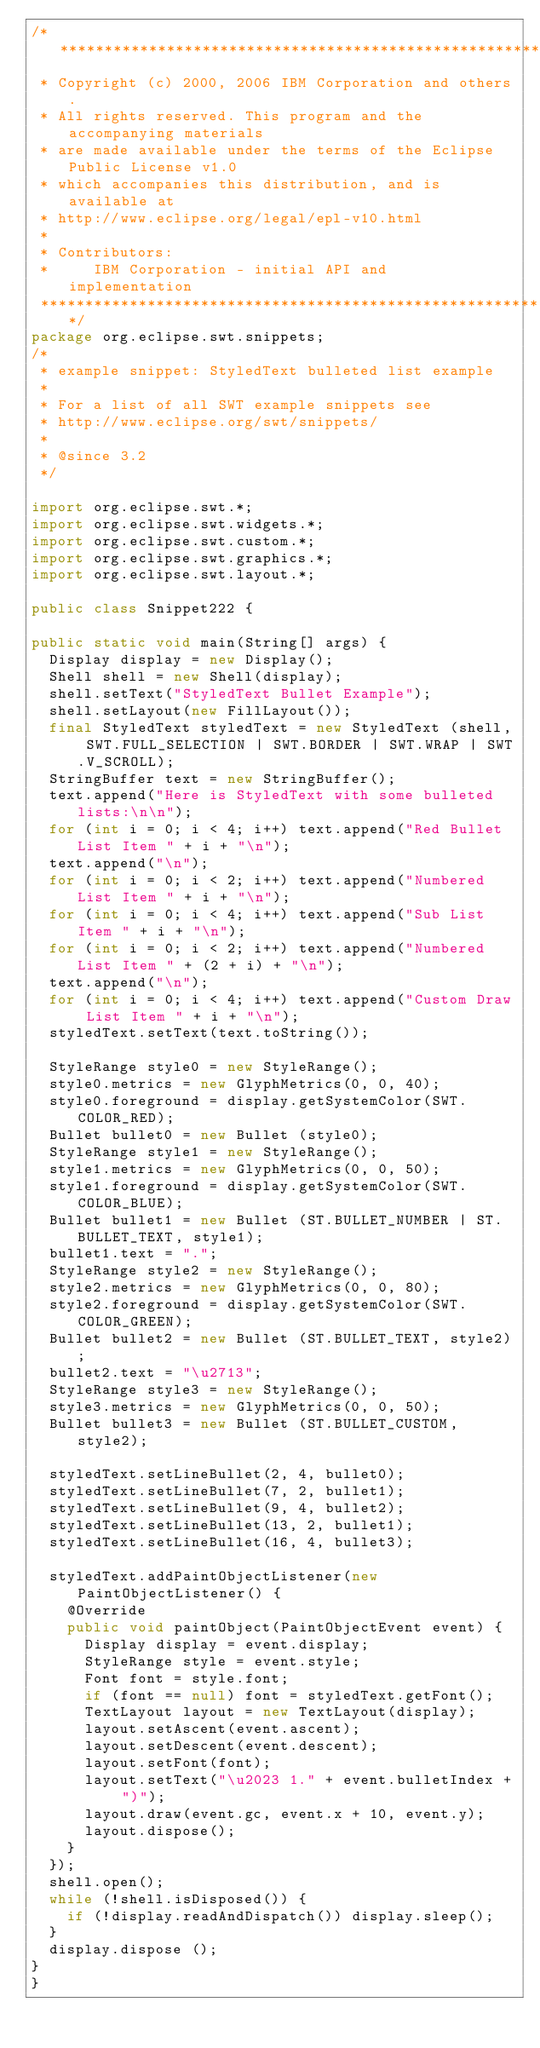<code> <loc_0><loc_0><loc_500><loc_500><_Java_>/*******************************************************************************
 * Copyright (c) 2000, 2006 IBM Corporation and others.
 * All rights reserved. This program and the accompanying materials
 * are made available under the terms of the Eclipse Public License v1.0
 * which accompanies this distribution, and is available at
 * http://www.eclipse.org/legal/epl-v10.html
 *
 * Contributors:
 *     IBM Corporation - initial API and implementation
 *******************************************************************************/
package org.eclipse.swt.snippets;
/* 
 * example snippet: StyledText bulleted list example
 *
 * For a list of all SWT example snippets see
 * http://www.eclipse.org/swt/snippets/
 * 
 * @since 3.2
 */

import org.eclipse.swt.*;
import org.eclipse.swt.widgets.*;
import org.eclipse.swt.custom.*;
import org.eclipse.swt.graphics.*;
import org.eclipse.swt.layout.*;

public class Snippet222 {
	
public static void main(String[] args) {	
	Display display = new Display();
	Shell shell = new Shell(display);
	shell.setText("StyledText Bullet Example");
	shell.setLayout(new FillLayout());
	final StyledText styledText = new StyledText (shell, SWT.FULL_SELECTION | SWT.BORDER | SWT.WRAP | SWT.V_SCROLL);
	StringBuffer text = new StringBuffer();
	text.append("Here is StyledText with some bulleted lists:\n\n");
	for (int i = 0; i < 4; i++) text.append("Red Bullet List Item " + i + "\n");
	text.append("\n");
	for (int i = 0; i < 2; i++) text.append("Numbered List Item " + i + "\n");
	for (int i = 0; i < 4; i++) text.append("Sub List Item " + i + "\n");
	for (int i = 0; i < 2; i++) text.append("Numbered List Item " + (2 + i) + "\n");
	text.append("\n");
	for (int i = 0; i < 4; i++) text.append("Custom Draw List Item " + i + "\n");	
	styledText.setText(text.toString());
		
	StyleRange style0 = new StyleRange();
	style0.metrics = new GlyphMetrics(0, 0, 40);
	style0.foreground = display.getSystemColor(SWT.COLOR_RED);
	Bullet bullet0 = new Bullet (style0);
	StyleRange style1 = new StyleRange();
	style1.metrics = new GlyphMetrics(0, 0, 50);
	style1.foreground = display.getSystemColor(SWT.COLOR_BLUE);
	Bullet bullet1 = new Bullet (ST.BULLET_NUMBER | ST.BULLET_TEXT, style1);
	bullet1.text = ".";
	StyleRange style2 = new StyleRange();
	style2.metrics = new GlyphMetrics(0, 0, 80);
	style2.foreground = display.getSystemColor(SWT.COLOR_GREEN);
	Bullet bullet2 = new Bullet (ST.BULLET_TEXT, style2);
	bullet2.text = "\u2713";
	StyleRange style3 = new StyleRange();
	style3.metrics = new GlyphMetrics(0, 0, 50);
	Bullet bullet3 = new Bullet (ST.BULLET_CUSTOM, style2);

	styledText.setLineBullet(2, 4, bullet0);
	styledText.setLineBullet(7, 2, bullet1);
	styledText.setLineBullet(9, 4, bullet2);
	styledText.setLineBullet(13, 2, bullet1);
	styledText.setLineBullet(16, 4, bullet3);

	styledText.addPaintObjectListener(new PaintObjectListener() {
		@Override
		public void paintObject(PaintObjectEvent event) {
			Display display = event.display;
			StyleRange style = event.style;
			Font font = style.font;
			if (font == null) font = styledText.getFont();
			TextLayout layout = new TextLayout(display);
			layout.setAscent(event.ascent);
			layout.setDescent(event.descent);
			layout.setFont(font);
			layout.setText("\u2023 1." + event.bulletIndex + ")");
			layout.draw(event.gc, event.x + 10, event.y);
			layout.dispose();
		}
	});
	shell.open();
	while (!shell.isDisposed()) {
		if (!display.readAndDispatch()) display.sleep();
	}
	display.dispose ();
}
}
</code> 